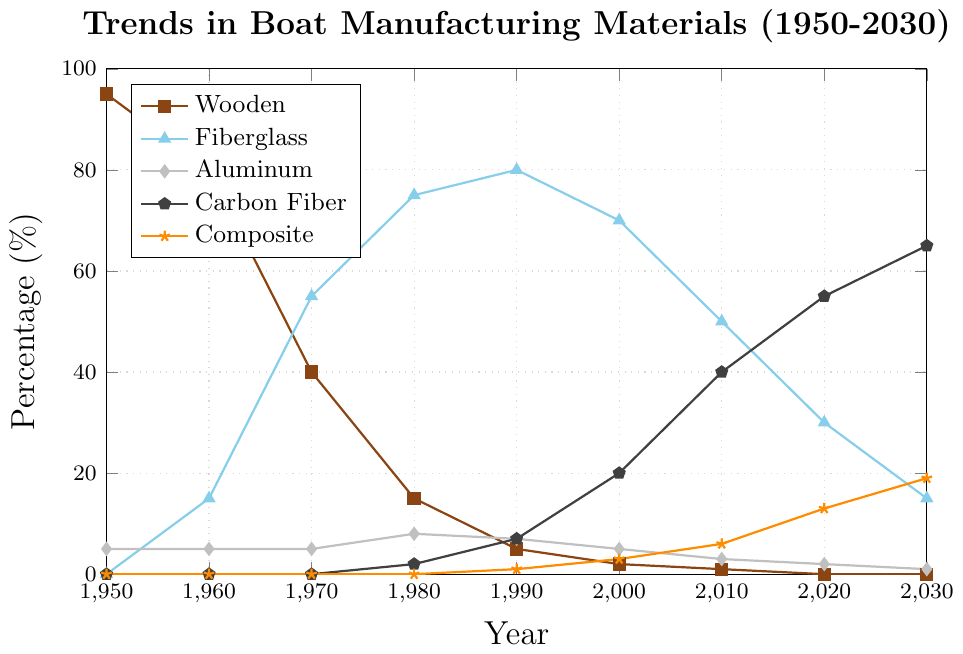What year did carbon fiber first appear as a manufacturing material? Carbon fiber first appears on the chart in the year where it has a non-zero percentage. This is in 1980.
Answer: 1980 In which decade did wooden boat usage drop the most significantly? To determine the decade with the largest drop, we look at the percentage values for wooden boats over each decade and calculate the difference. The largest drop is between 1960 (80%) and 1970 (40%), where the usage drops by 40%.
Answer: 1960 to 1970 Which material has shown the most consistent decrease in usage over the years? To identify the material with the most consistent decrease, observe the lines on the chart and see which one continuously goes down smoothly without increasing at any point. The wooden material usage consistently decreases.
Answer: Wooden By how much did the usage of fiberglass decrease from 1990 to 2030? The usage of fiberglass in 1990 was 80% and it is projected to be 15% in 2030. Thus, the decrease is calculated as 80% - 15% = 65%.
Answer: 65% In 2020, which material had the second-highest usage percentage? According to the chart, in 2020 the percentages are Carbon Fiber (55%), Fiberglass (30%), Aluminum (2%), Composite (13%), and Wood (0%). The second-highest is Fiberglass with 30%.
Answer: Fiberglass What is the combined percentage of carbon fiber and composite materials in 2010? The combined percentage is found by adding the percentages of carbon fiber (40%) and composite (6%) in 2010, so 40% + 6% = 46%.
Answer: 46% In which year did the percentage of composite materials reach double digits for the first time? The percentage of composite materials first reaches double digits at 13% in the year 2020.
Answer: 2020 How many years did it take for the use of wooden materials to drop to zero from 1950? Wooden materials were used at 95% in 1950 and dropped to 0% in 2020. The number of years for this decline is 2020 - 1950 = 70 years.
Answer: 70 years Which material had the highest percentage usage in 1990? According to the chart, in 1990 the highest percentage usage was for Fiberglass at 80%.
Answer: Fiberglass 